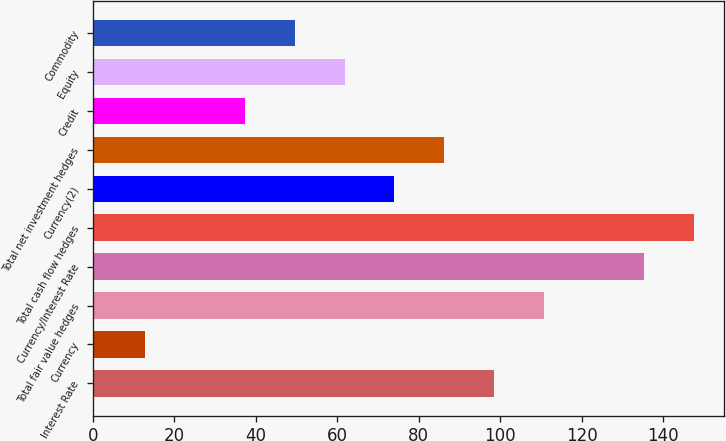Convert chart. <chart><loc_0><loc_0><loc_500><loc_500><bar_chart><fcel>Interest Rate<fcel>Currency<fcel>Total fair value hedges<fcel>Currency/Interest Rate<fcel>Total cash flow hedges<fcel>Currency(2)<fcel>Total net investment hedges<fcel>Credit<fcel>Equity<fcel>Commodity<nl><fcel>98.53<fcel>12.78<fcel>110.78<fcel>135.28<fcel>147.53<fcel>74.03<fcel>86.28<fcel>37.28<fcel>61.78<fcel>49.53<nl></chart> 